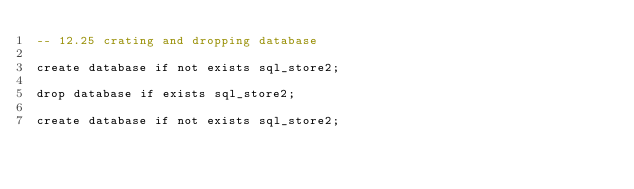Convert code to text. <code><loc_0><loc_0><loc_500><loc_500><_SQL_>-- 12.25 crating and dropping database

create database if not exists sql_store2;

drop database if exists sql_store2;

create database if not exists sql_store2;</code> 